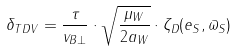<formula> <loc_0><loc_0><loc_500><loc_500>\delta _ { T D V } = \frac { \tau } { v _ { B \bot } } \cdot \sqrt { \frac { \mu _ { W } } { 2 a _ { W } } } \cdot \zeta _ { D } ( e _ { S } , \varpi _ { S } )</formula> 